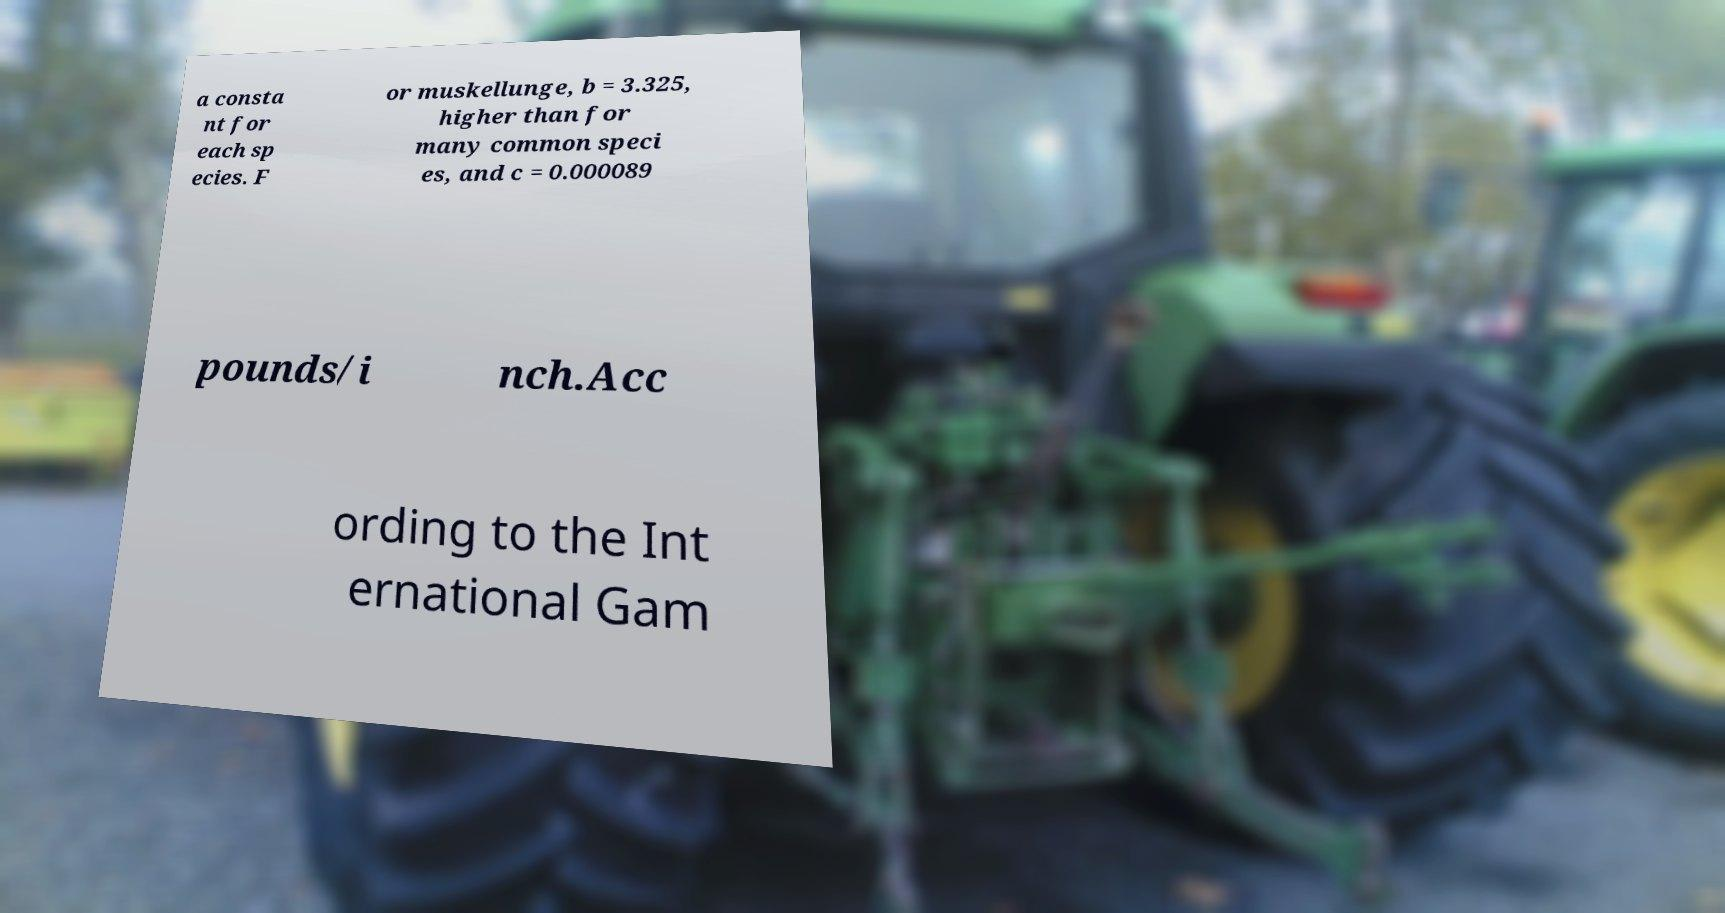What messages or text are displayed in this image? I need them in a readable, typed format. a consta nt for each sp ecies. F or muskellunge, b = 3.325, higher than for many common speci es, and c = 0.000089 pounds/i nch.Acc ording to the Int ernational Gam 